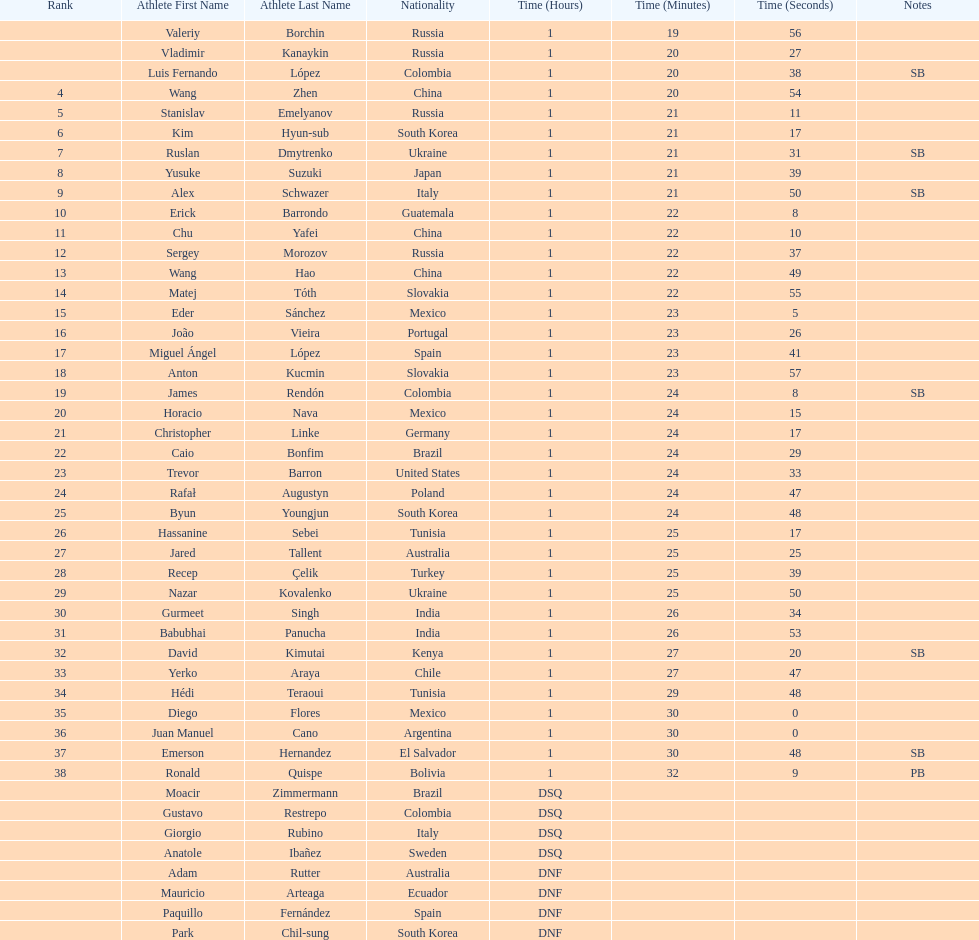What is the number of japanese in the top 10? 1. 